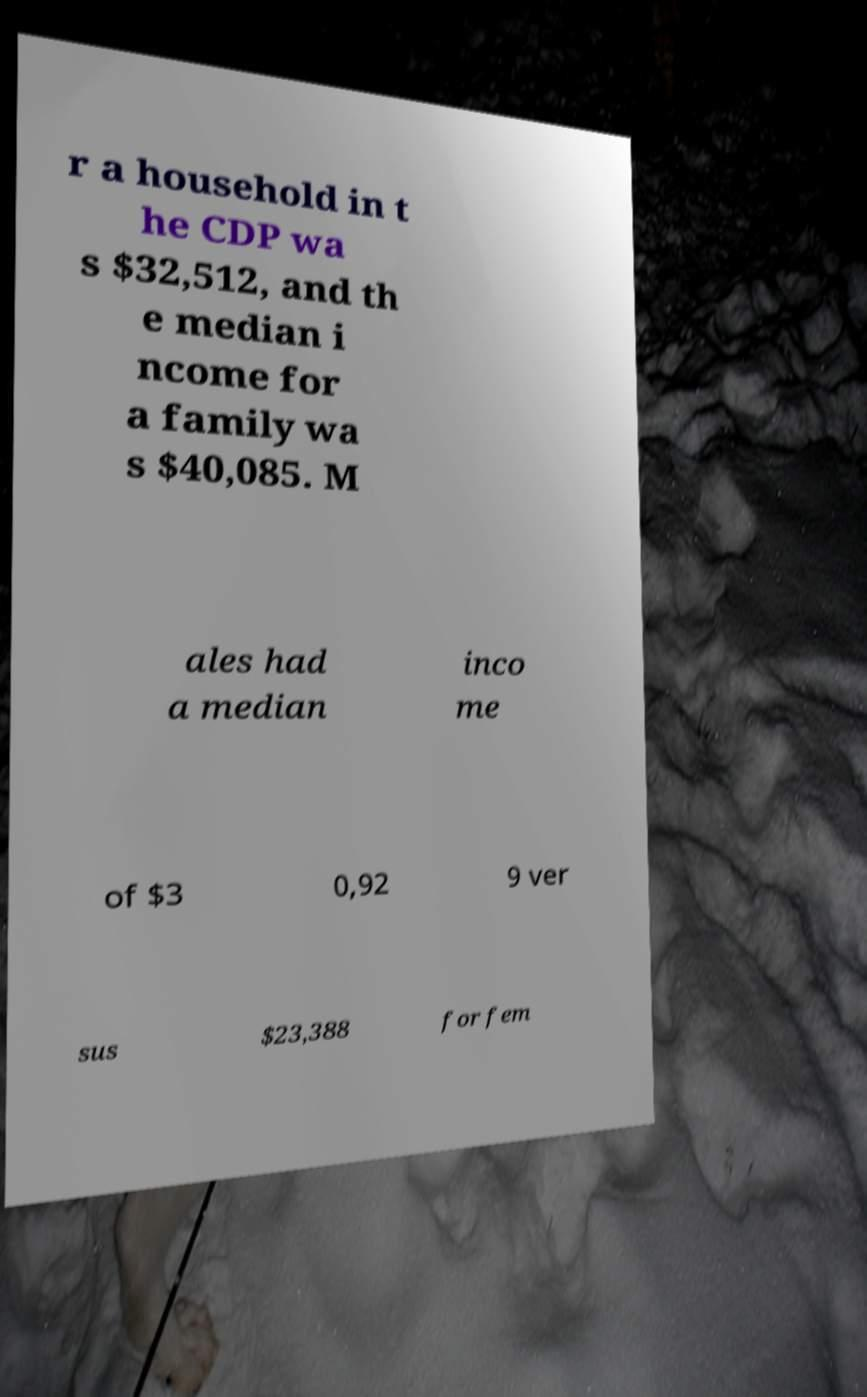Can you accurately transcribe the text from the provided image for me? r a household in t he CDP wa s $32,512, and th e median i ncome for a family wa s $40,085. M ales had a median inco me of $3 0,92 9 ver sus $23,388 for fem 